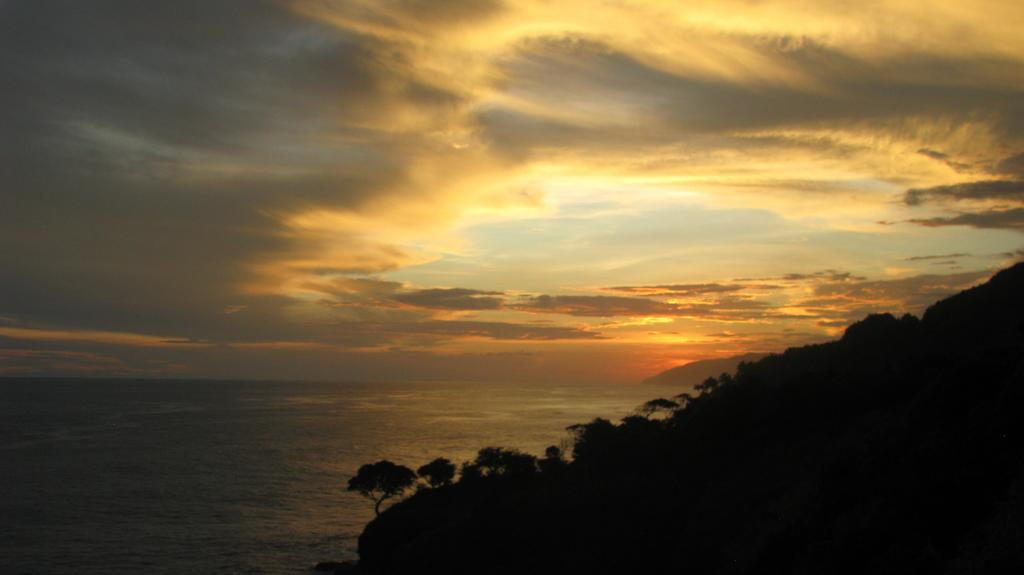What type of vegetation is present in the front of the image? There are trees in the front of the image. What can be seen in the background of the image? Water, clouds, and the sky are visible in the background of the image. What is the weight of the coach in the image? There is no coach present in the image, so it is not possible to determine its weight. Can you describe the kiss between the clouds and the water in the image? There is no kiss between the clouds and the water in the image; they are separate elements in the background. 